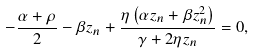<formula> <loc_0><loc_0><loc_500><loc_500>- \frac { \alpha + \rho } { 2 } - \beta z _ { n } + \frac { \eta \left ( \alpha z _ { n } + \beta z _ { n } ^ { 2 } \right ) } { \gamma + 2 \eta z _ { n } } = 0 ,</formula> 